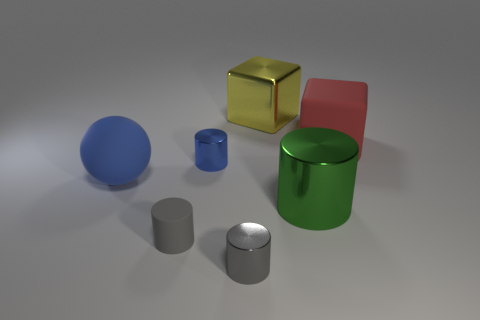There is a shiny thing right of the yellow shiny thing; what is its shape?
Your answer should be compact. Cylinder. Do the big green thing and the matte object that is to the right of the large green cylinder have the same shape?
Provide a succinct answer. No. There is a metallic thing that is left of the big green metallic object and in front of the blue matte sphere; how big is it?
Give a very brief answer. Small. The rubber object that is both on the left side of the large green shiny cylinder and behind the big green metal thing is what color?
Make the answer very short. Blue. Are there fewer gray cylinders on the left side of the small blue thing than cylinders left of the small gray metal object?
Your answer should be compact. Yes. Are there any other things of the same color as the sphere?
Your response must be concise. Yes. What is the shape of the large blue matte thing?
Your answer should be very brief. Sphere. There is a big cylinder that is made of the same material as the yellow object; what color is it?
Keep it short and to the point. Green. Is the number of tiny blue objects greater than the number of big objects?
Offer a terse response. No. Is there a tiny brown metal object?
Your answer should be very brief. No. 